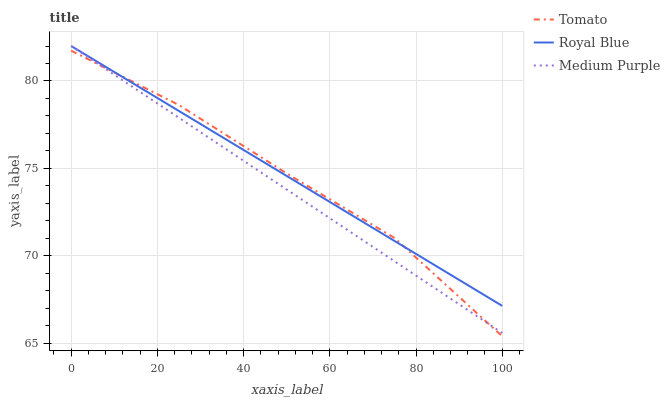Does Medium Purple have the minimum area under the curve?
Answer yes or no. Yes. Does Royal Blue have the maximum area under the curve?
Answer yes or no. Yes. Does Royal Blue have the minimum area under the curve?
Answer yes or no. No. Does Medium Purple have the maximum area under the curve?
Answer yes or no. No. Is Royal Blue the smoothest?
Answer yes or no. Yes. Is Tomato the roughest?
Answer yes or no. Yes. Is Medium Purple the roughest?
Answer yes or no. No. Does Tomato have the lowest value?
Answer yes or no. Yes. Does Medium Purple have the lowest value?
Answer yes or no. No. Does Medium Purple have the highest value?
Answer yes or no. Yes. Does Medium Purple intersect Tomato?
Answer yes or no. Yes. Is Medium Purple less than Tomato?
Answer yes or no. No. Is Medium Purple greater than Tomato?
Answer yes or no. No. 